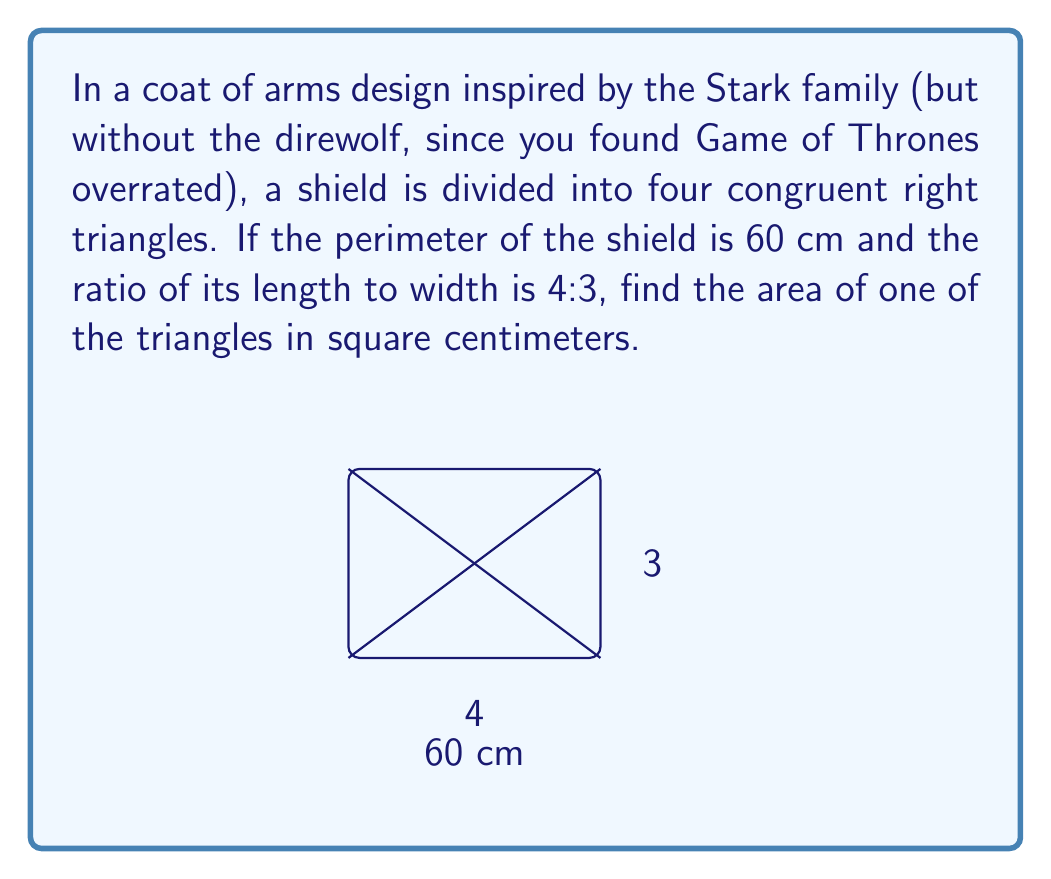Help me with this question. Let's approach this step-by-step:

1) Let the width of the shield be $x$ cm. Then, the length is $\frac{4x}{3}$ cm.

2) The perimeter of the shield is given by:

   $2x + 2(\frac{4x}{3}) = 60$

3) Simplifying:

   $2x + \frac{8x}{3} = 60$
   $\frac{6x}{3} + \frac{8x}{3} = 60$
   $\frac{14x}{3} = 60$

4) Solving for $x$:

   $x = \frac{60 \cdot 3}{14} = \frac{180}{14} = \frac{90}{7} \approx 12.86$ cm

5) The width is $\frac{90}{7}$ cm and the length is $\frac{4 \cdot 90}{3 \cdot 7} = \frac{120}{7}$ cm.

6) The area of the shield is:

   $A = \frac{90}{7} \cdot \frac{120}{7} = \frac{10800}{49}$ sq cm

7) The shield is divided into four congruent right triangles. The area of one triangle is:

   $A_{triangle} = \frac{1}{4} \cdot \frac{10800}{49} = \frac{2700}{49}$ sq cm
Answer: $\frac{2700}{49}$ sq cm 